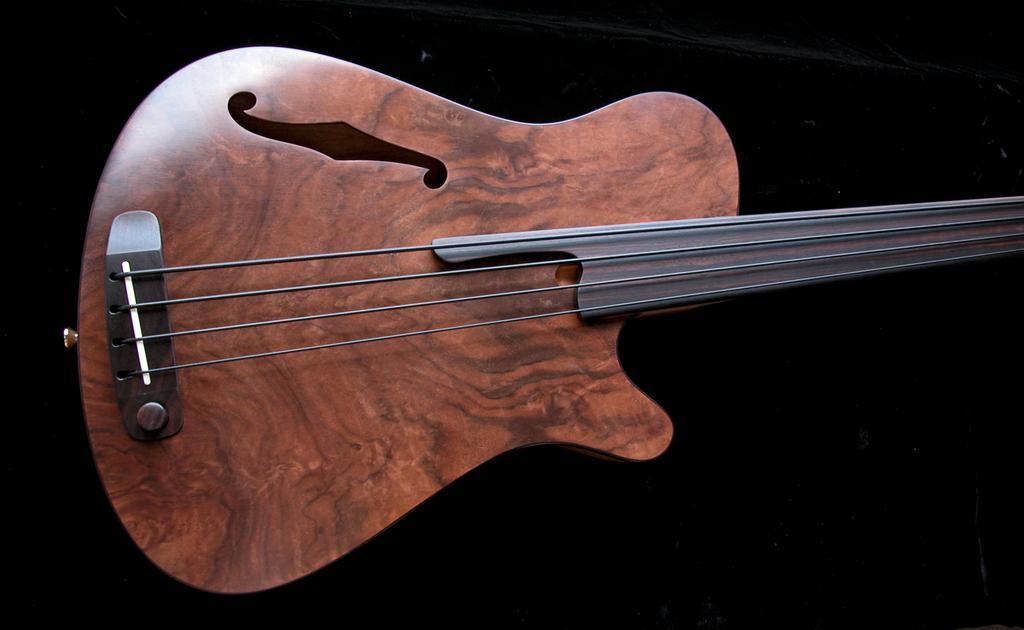Could you give a brief overview of what you see in this image? In a picture there is one guitar is placed. 